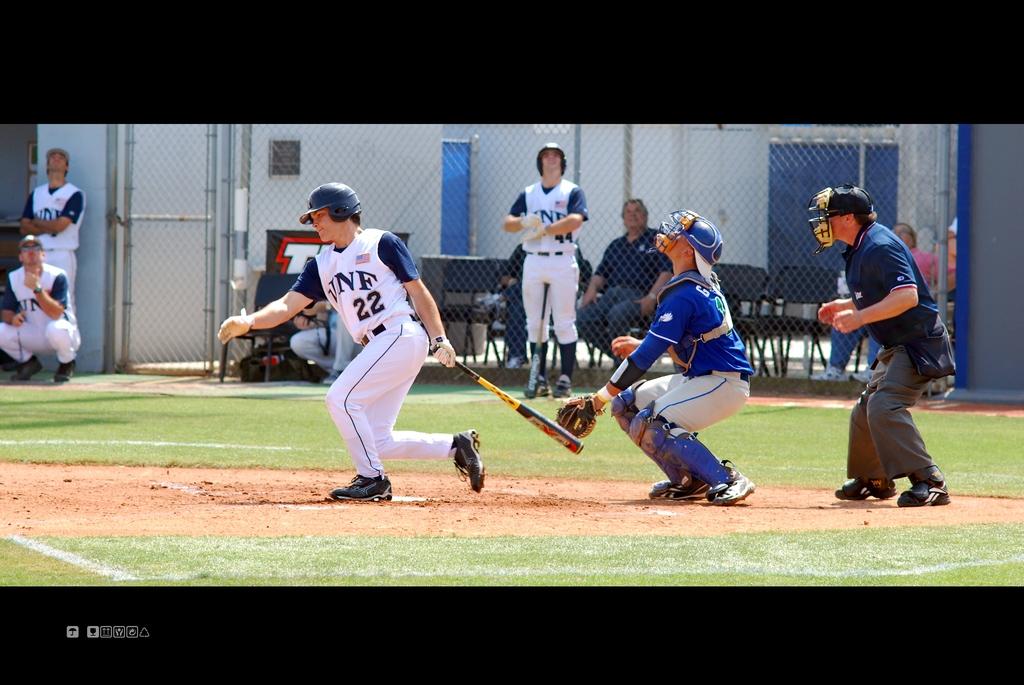What number is the player batting?
Your answer should be compact. 22. What is the name written on the jersey?
Your answer should be compact. Unanswerable. 